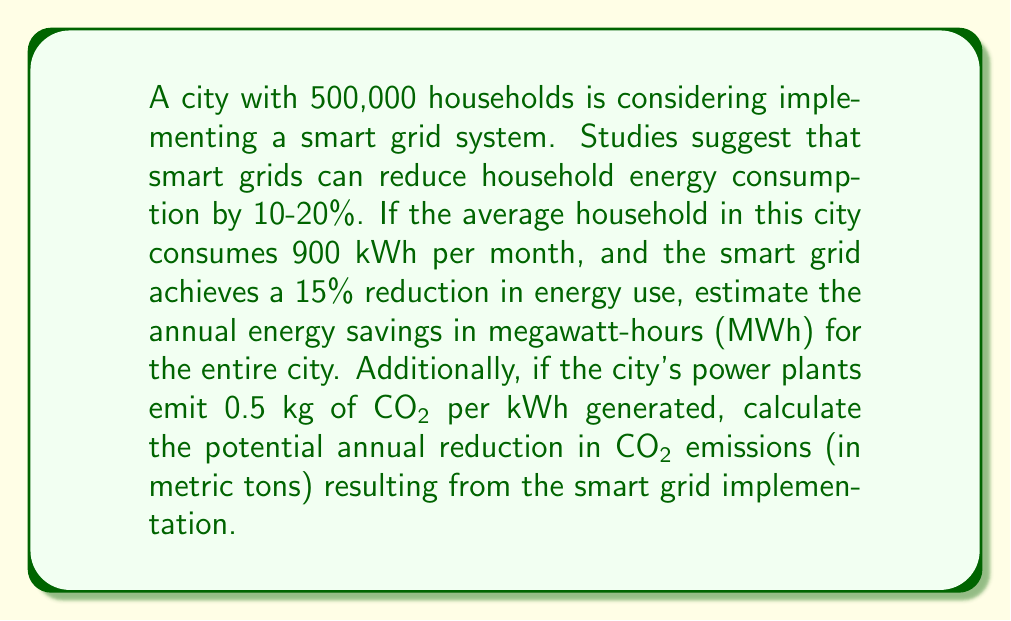Help me with this question. Let's break this problem down into steps:

1. Calculate the current monthly energy consumption for the entire city:
   $$ 500,000 \text{ households} \times 900 \text{ kWh/month} = 450,000,000 \text{ kWh/month} $$

2. Calculate the monthly energy savings with a 15% reduction:
   $$ 450,000,000 \text{ kWh/month} \times 0.15 = 67,500,000 \text{ kWh/month} $$

3. Convert monthly savings to annual savings:
   $$ 67,500,000 \text{ kWh/month} \times 12 \text{ months} = 810,000,000 \text{ kWh/year} $$

4. Convert kWh to MWh:
   $$ 810,000,000 \text{ kWh/year} \div 1,000 \text{ kWh/MWh} = 810,000 \text{ MWh/year} $$

5. Calculate the annual reduction in CO2 emissions:
   $$ 810,000,000 \text{ kWh/year} \times 0.5 \text{ kg CO2/kWh} = 405,000,000 \text{ kg CO2/year} $$

6. Convert kg to metric tons:
   $$ 405,000,000 \text{ kg CO2/year} \div 1,000 \text{ kg/metric ton} = 405,000 \text{ metric tons CO2/year} $$
Answer: The annual energy savings for the entire city would be 810,000 MWh, and the potential annual reduction in CO2 emissions would be 405,000 metric tons. 